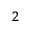Convert formula to latex. <formula><loc_0><loc_0><loc_500><loc_500>^ { 2 }</formula> 